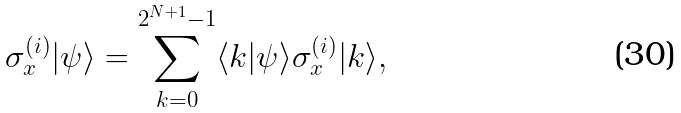Convert formula to latex. <formula><loc_0><loc_0><loc_500><loc_500>\sigma _ { x } ^ { ( i ) } | \psi \rangle = \sum _ { k = 0 } ^ { 2 ^ { N + 1 } - 1 } \langle k | \psi \rangle \sigma _ { x } ^ { ( i ) } | k \rangle ,</formula> 